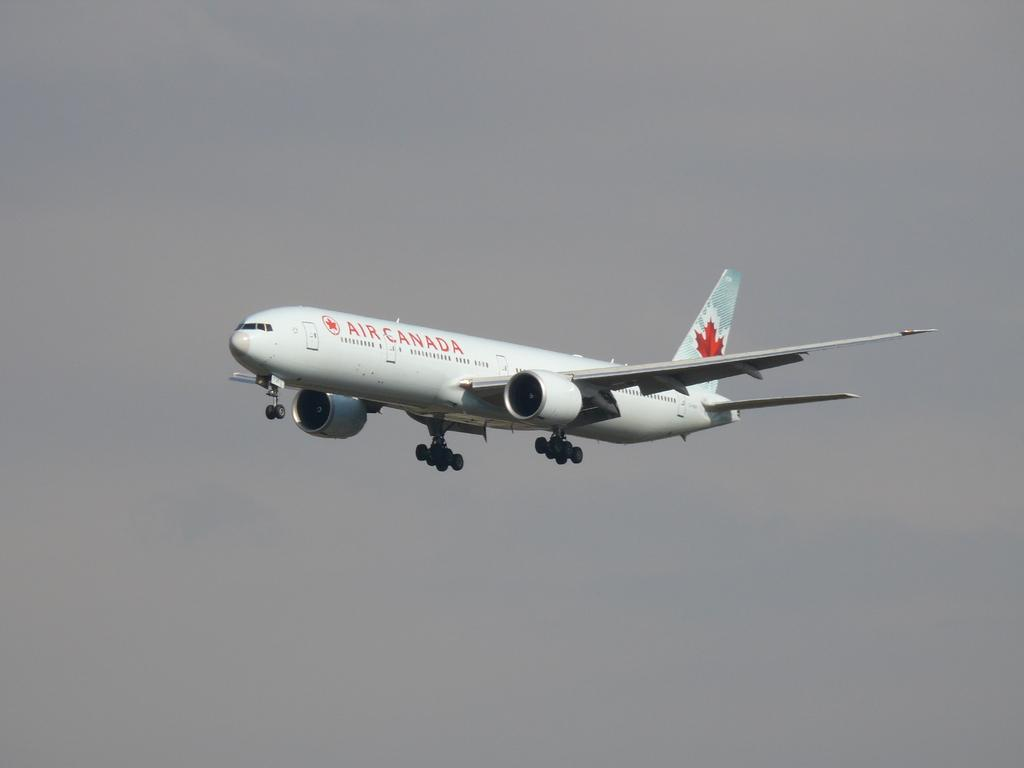<image>
Give a short and clear explanation of the subsequent image. An airplane in the sky with a maple leaf from the company Air Canada 